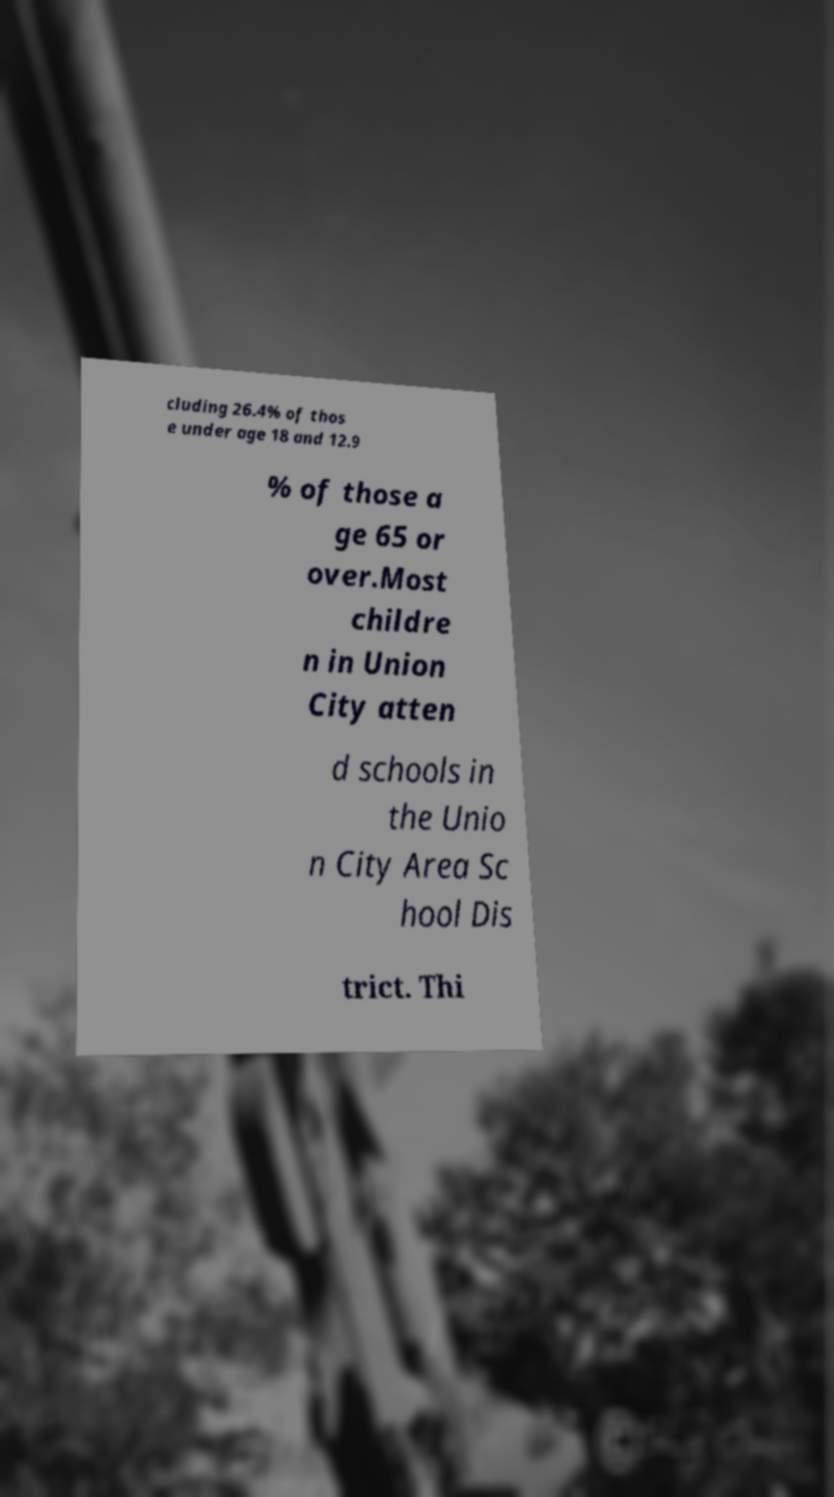Can you accurately transcribe the text from the provided image for me? cluding 26.4% of thos e under age 18 and 12.9 % of those a ge 65 or over.Most childre n in Union City atten d schools in the Unio n City Area Sc hool Dis trict. Thi 